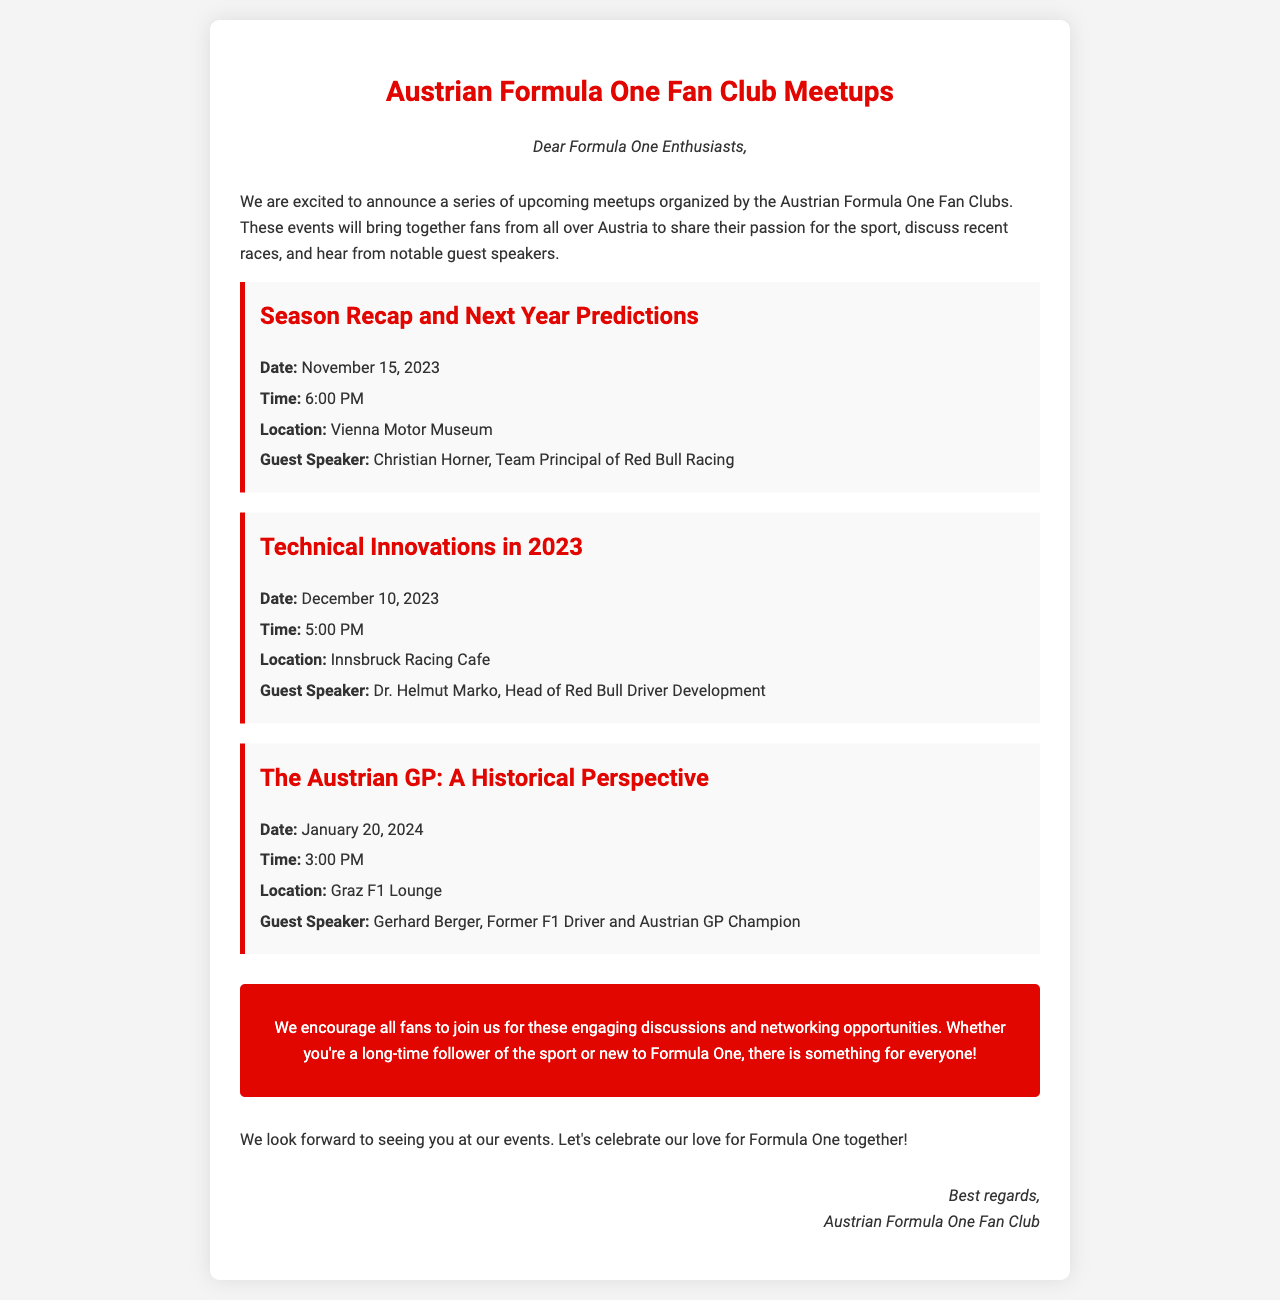What is the first event listed? The first event listed in the document is "Season Recap and Next Year Predictions."
Answer: Season Recap and Next Year Predictions When is the event with Christian Horner scheduled? Christian Horner is the guest speaker for the event on November 15, 2023.
Answer: November 15, 2023 Where will the meeting about Technical Innovations be held? The event on Technical Innovations will take place at Innsbruck Racing Cafe.
Answer: Innsbruck Racing Cafe Who is the guest speaker for the Historical Perspective event? The guest speaker for "The Austrian GP: A Historical Perspective" is Gerhard Berger.
Answer: Gerhard Berger What date will the Technical Innovations discussion occur? The discussion on Technical Innovations is scheduled for December 10, 2023.
Answer: December 10, 2023 How many events are mentioned in the document? There are three events mentioned in the document.
Answer: Three What is the main purpose of the meetups according to the document? The meetups aim to share passion for the sport, discuss races, and hear from guest speakers.
Answer: Share passion for the sport What is emphasized for all fans in the call to action? The call to action encourages all fans to join for discussions and networking opportunities.
Answer: Join for discussions and networking opportunities What is the starting time for the event on January 20, 2024? The event on January 20, 2024, starts at 3:00 PM.
Answer: 3:00 PM 